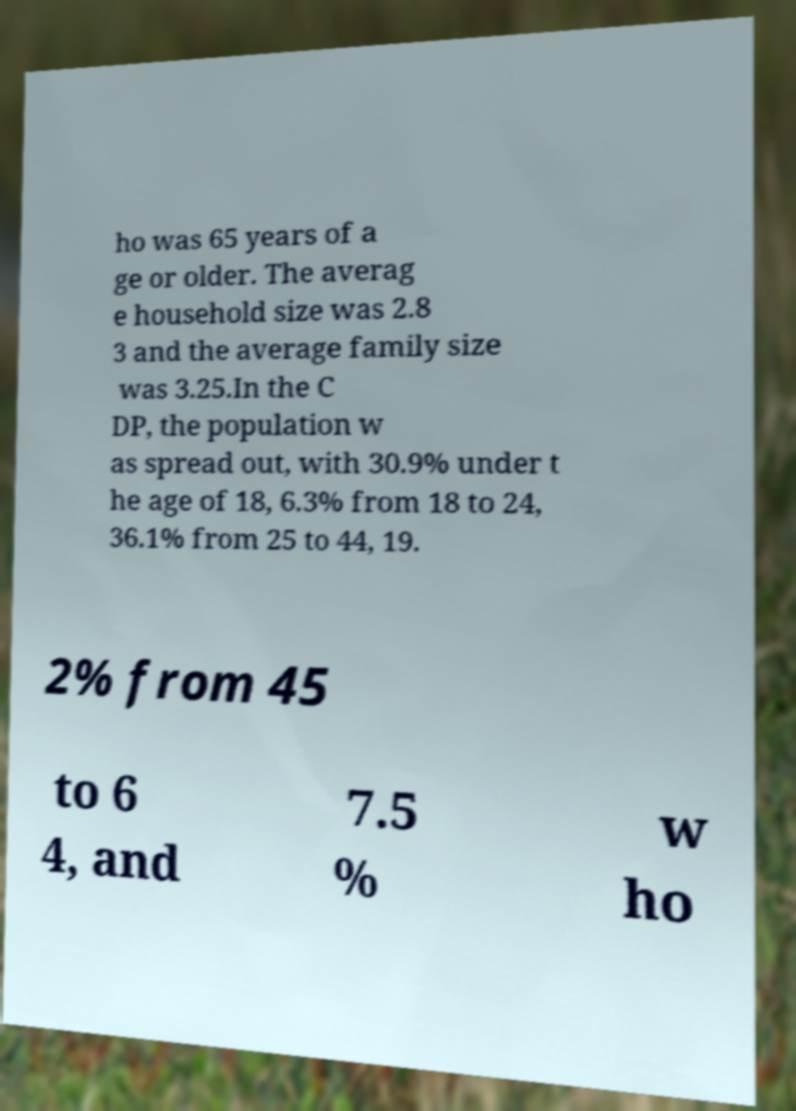Can you accurately transcribe the text from the provided image for me? ho was 65 years of a ge or older. The averag e household size was 2.8 3 and the average family size was 3.25.In the C DP, the population w as spread out, with 30.9% under t he age of 18, 6.3% from 18 to 24, 36.1% from 25 to 44, 19. 2% from 45 to 6 4, and 7.5 % w ho 